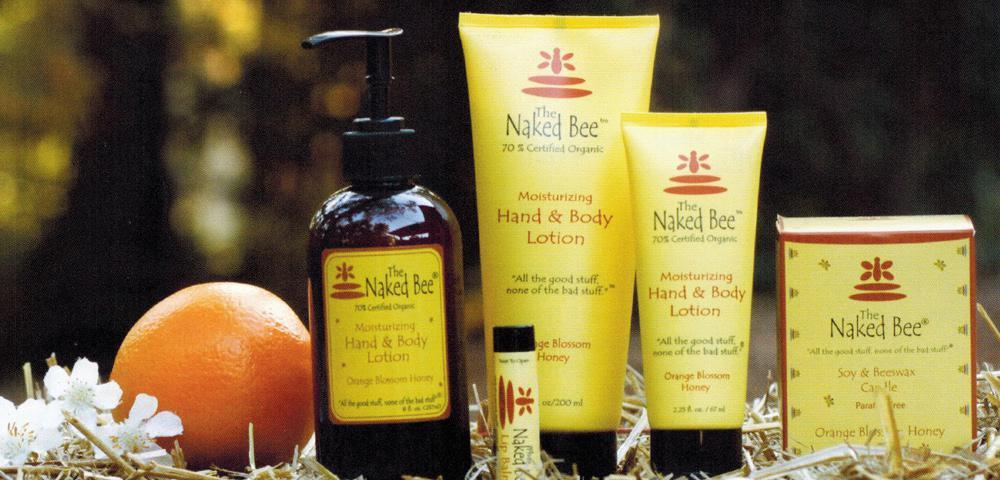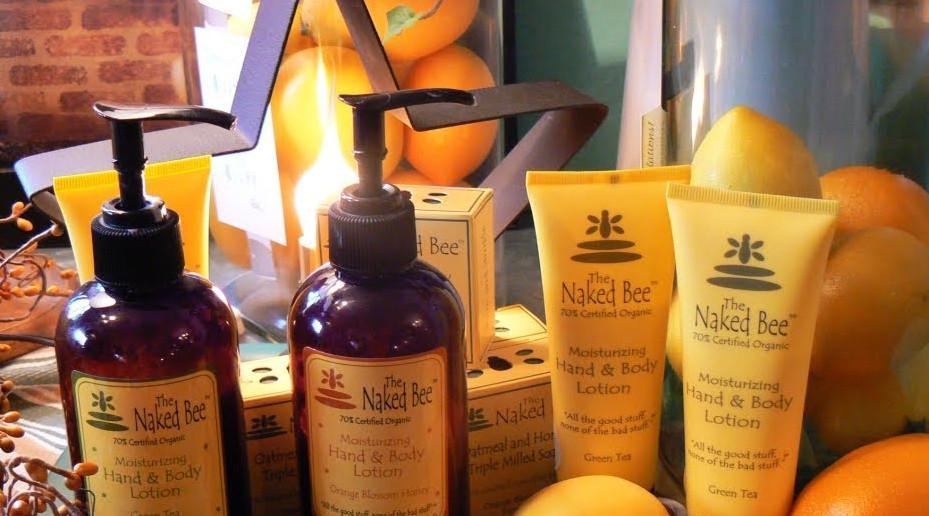The first image is the image on the left, the second image is the image on the right. Examine the images to the left and right. Is the description "Each image includes yellow tubes that stand on flat black flip-top caps, but only the right image includes a dark brown bottle with a black pump top." accurate? Answer yes or no. No. 